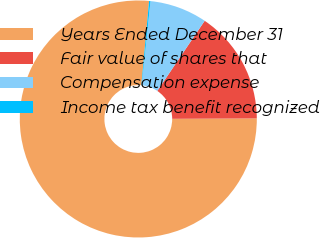Convert chart. <chart><loc_0><loc_0><loc_500><loc_500><pie_chart><fcel>Years Ended December 31<fcel>Fair value of shares that<fcel>Compensation expense<fcel>Income tax benefit recognized<nl><fcel>76.53%<fcel>15.46%<fcel>7.82%<fcel>0.19%<nl></chart> 